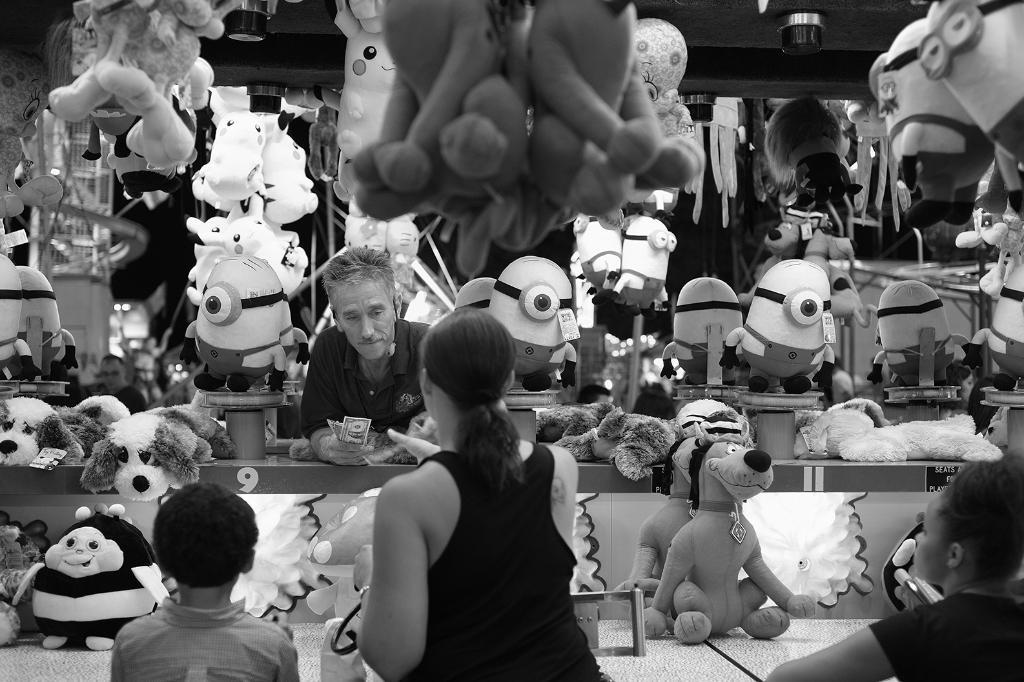How many people are in the image? There are persons in the image, but the exact number is not specified. What else can be seen in the image besides the persons? There is a group of toys in the image. What type of ghost can be seen interacting with the toys in the image? There is no ghost present in the image; it features persons and a group of toys. 